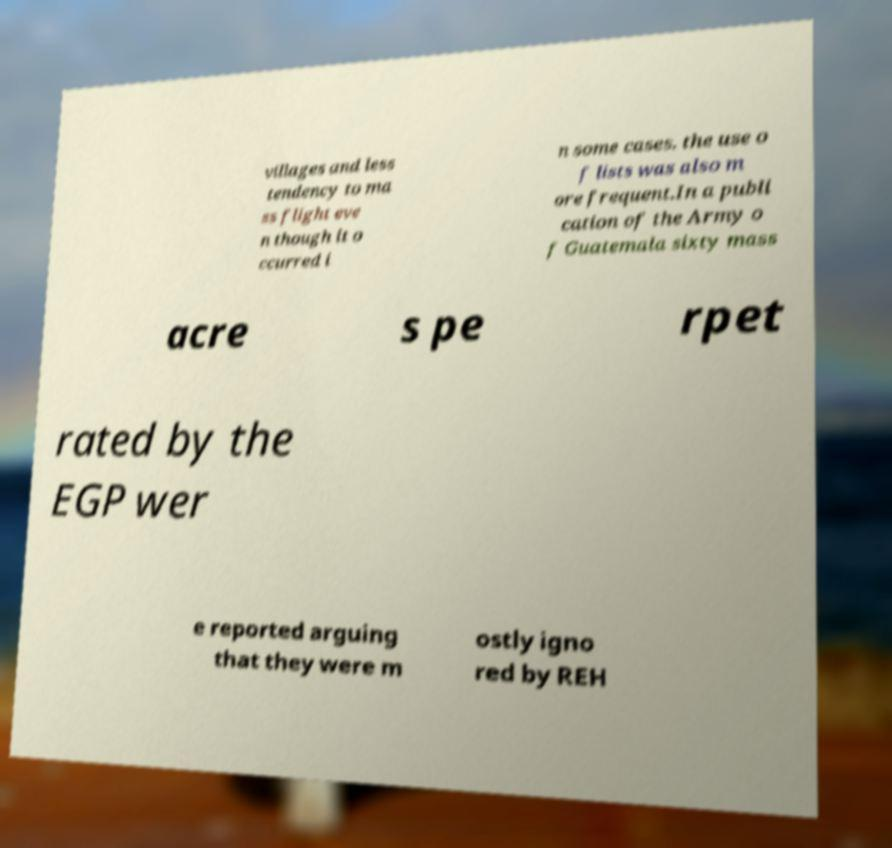Can you accurately transcribe the text from the provided image for me? villages and less tendency to ma ss flight eve n though it o ccurred i n some cases. the use o f lists was also m ore frequent.In a publi cation of the Army o f Guatemala sixty mass acre s pe rpet rated by the EGP wer e reported arguing that they were m ostly igno red by REH 